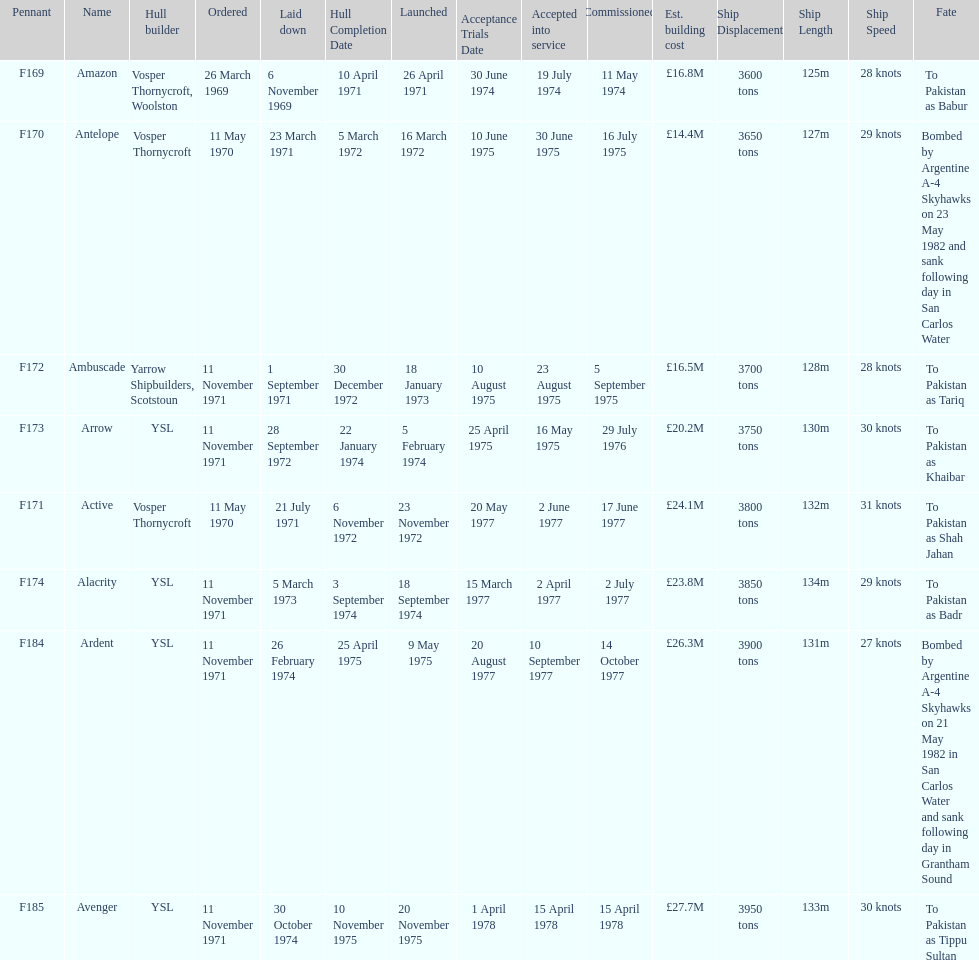The arrow was ordered on november 11, 1971. what was the previous ship? Ambuscade. 